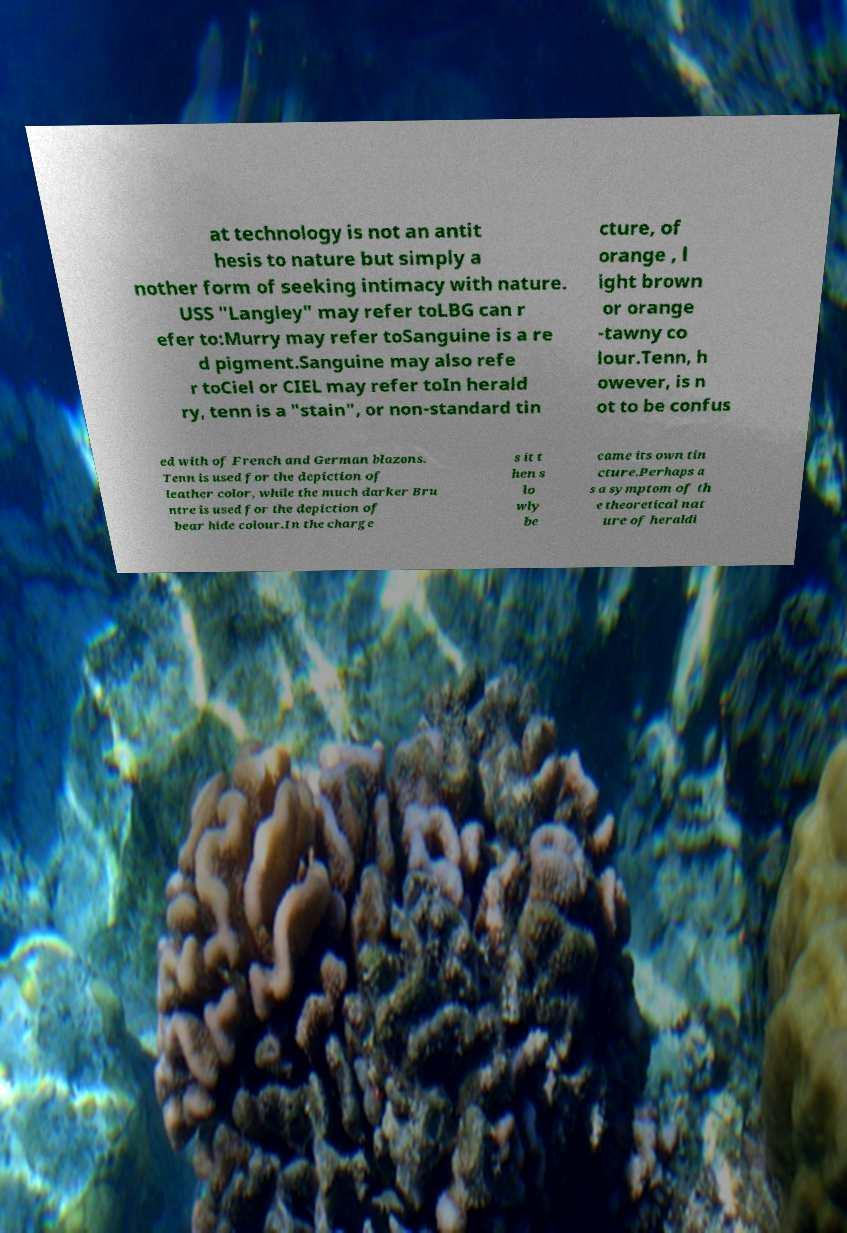There's text embedded in this image that I need extracted. Can you transcribe it verbatim? at technology is not an antit hesis to nature but simply a nother form of seeking intimacy with nature. USS "Langley" may refer toLBG can r efer to:Murry may refer toSanguine is a re d pigment.Sanguine may also refe r toCiel or CIEL may refer toIn herald ry, tenn is a "stain", or non-standard tin cture, of orange , l ight brown or orange -tawny co lour.Tenn, h owever, is n ot to be confus ed with of French and German blazons. Tenn is used for the depiction of leather color, while the much darker Bru ntre is used for the depiction of bear hide colour.In the charge s it t hen s lo wly be came its own tin cture.Perhaps a s a symptom of th e theoretical nat ure of heraldi 